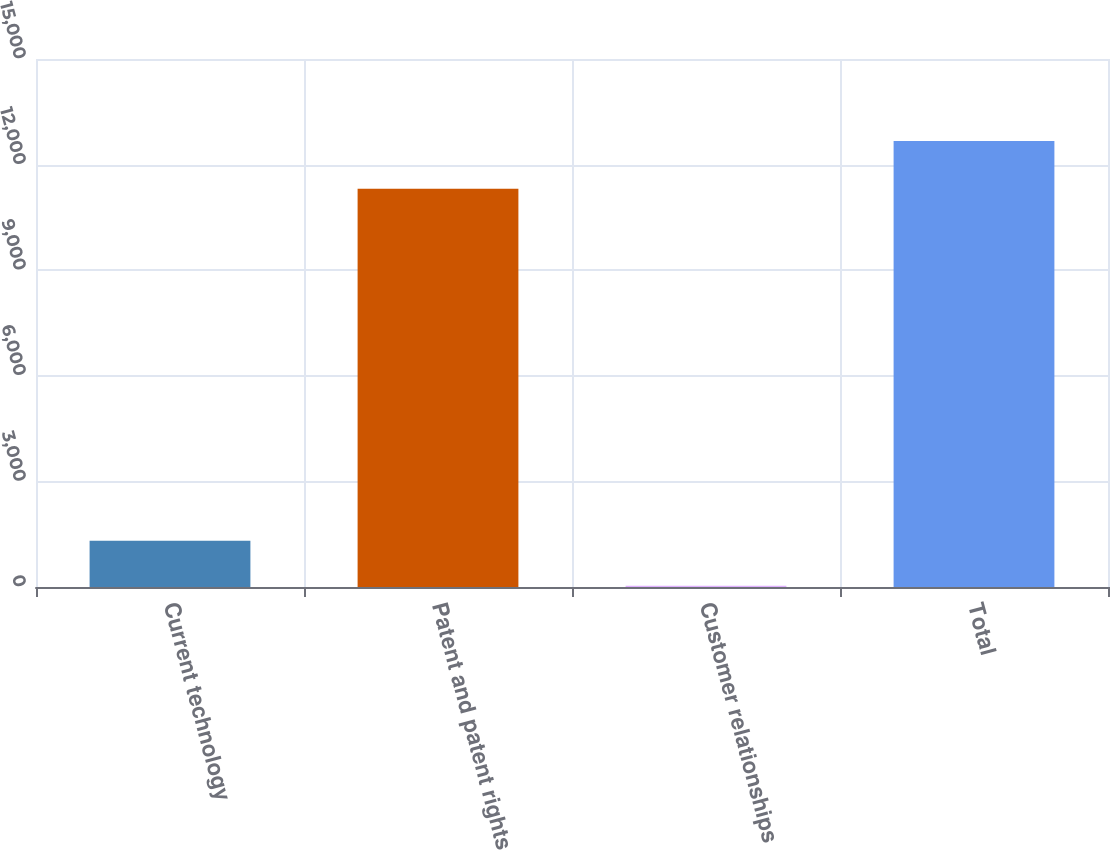<chart> <loc_0><loc_0><loc_500><loc_500><bar_chart><fcel>Current technology<fcel>Patent and patent rights<fcel>Customer relationships<fcel>Total<nl><fcel>1315<fcel>11313<fcel>39<fcel>12667<nl></chart> 